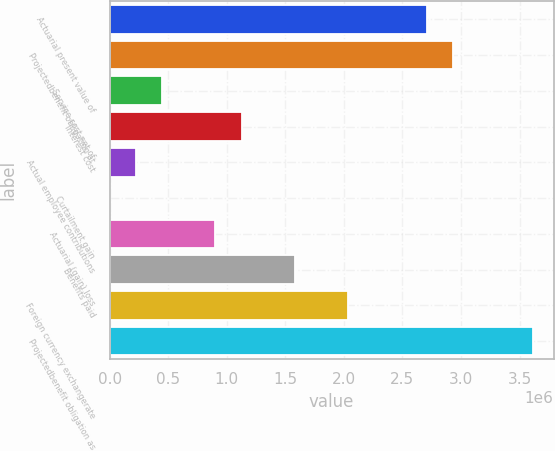<chart> <loc_0><loc_0><loc_500><loc_500><bar_chart><fcel>Actuarial present value of<fcel>Projectedbenefit obligation at<fcel>Service cost net of<fcel>Interest cost<fcel>Actual employee contributions<fcel>Curtailment gain<fcel>Actuarial (gain) loss<fcel>Benefits paid<fcel>Foreign currency exchangerate<fcel>Projectedbenefit obligation as<nl><fcel>2.70823e+06<fcel>2.93387e+06<fcel>451817<fcel>1.12874e+06<fcel>226176<fcel>535<fcel>903099<fcel>1.58002e+06<fcel>2.0313e+06<fcel>3.61079e+06<nl></chart> 